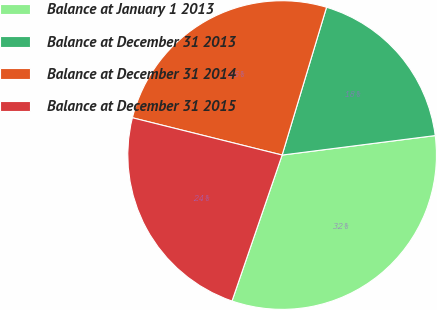Convert chart to OTSL. <chart><loc_0><loc_0><loc_500><loc_500><pie_chart><fcel>Balance at January 1 2013<fcel>Balance at December 31 2013<fcel>Balance at December 31 2014<fcel>Balance at December 31 2015<nl><fcel>32.28%<fcel>18.34%<fcel>25.76%<fcel>23.62%<nl></chart> 